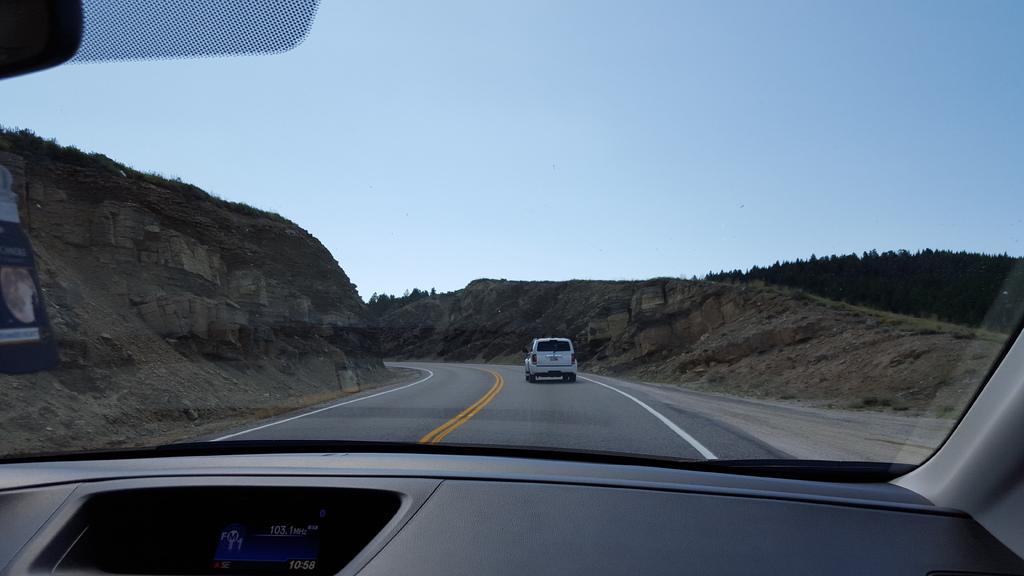Can you describe this image briefly? The picture is taken inside a vehicle. This is a screen. through the glass we can see there is a car running on the road. On both sides there are hills. In the background there are trees. The sky is clear. 